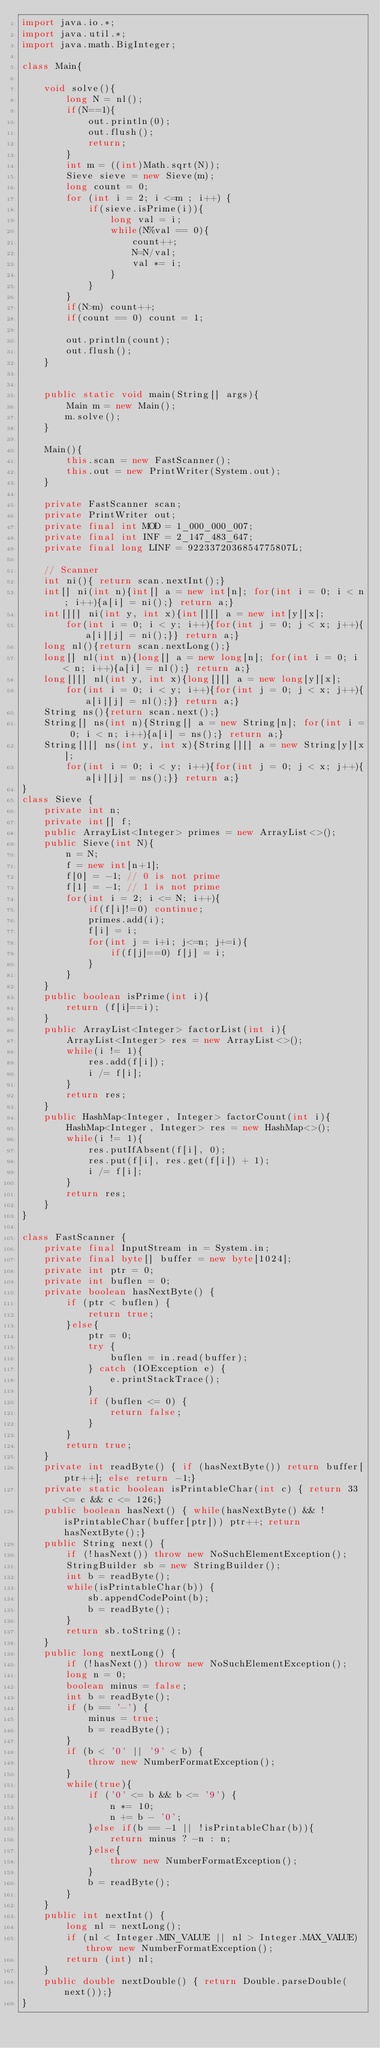Convert code to text. <code><loc_0><loc_0><loc_500><loc_500><_Java_>import java.io.*;
import java.util.*;
import java.math.BigInteger;

class Main{

    void solve(){
        long N = nl();
        if(N==1){
            out.println(0);
            out.flush();
            return;
        }
        int m = ((int)Math.sqrt(N));
        Sieve sieve = new Sieve(m);
        long count = 0;
        for (int i = 2; i <=m ; i++) {
            if(sieve.isPrime(i)){
                long val = i;
                while(N%val == 0){
                    count++;
                    N=N/val;
                    val *= i;
                }
            }
        }
        if(N>m) count++;
        if(count == 0) count = 1;

        out.println(count);
        out.flush();
    } 


    public static void main(String[] args){
        Main m = new Main();
        m.solve();
    }

    Main(){
        this.scan = new FastScanner();
        this.out = new PrintWriter(System.out);
    }

    private FastScanner scan;
    private PrintWriter out;
    private final int MOD = 1_000_000_007;
    private final int INF = 2_147_483_647;
    private final long LINF = 9223372036854775807L;

    // Scanner
    int ni(){ return scan.nextInt();}
    int[] ni(int n){int[] a = new int[n]; for(int i = 0; i < n; i++){a[i] = ni();} return a;}
    int[][] ni(int y, int x){int[][] a = new int[y][x];
        for(int i = 0; i < y; i++){for(int j = 0; j < x; j++){a[i][j] = ni();}} return a;}
    long nl(){return scan.nextLong();}
    long[] nl(int n){long[] a = new long[n]; for(int i = 0; i < n; i++){a[i] = nl();} return a;}
    long[][] nl(int y, int x){long[][] a = new long[y][x];
        for(int i = 0; i < y; i++){for(int j = 0; j < x; j++){a[i][j] = nl();}} return a;}
    String ns(){return scan.next();}
    String[] ns(int n){String[] a = new String[n]; for(int i = 0; i < n; i++){a[i] = ns();} return a;}
    String[][] ns(int y, int x){String[][] a = new String[y][x];
        for(int i = 0; i < y; i++){for(int j = 0; j < x; j++){a[i][j] = ns();}} return a;}
}
class Sieve {
    private int n;
    private int[] f;
    public ArrayList<Integer> primes = new ArrayList<>();
    public Sieve(int N){
        n = N;
        f = new int[n+1];
        f[0] = -1; // 0 is not prime
        f[1] = -1; // 1 is not prime
        for(int i = 2; i <= N; i++){
            if(f[i]!=0) continue;
            primes.add(i);
            f[i] = i;
            for(int j = i+i; j<=n; j+=i){
                if(f[j]==0) f[j] = i;
            }
        }
    }
    public boolean isPrime(int i){
        return (f[i]==i);
    } 
    public ArrayList<Integer> factorList(int i){
        ArrayList<Integer> res = new ArrayList<>();
        while(i != 1){
            res.add(f[i]);
            i /= f[i];
        }
        return res;
    }
    public HashMap<Integer, Integer> factorCount(int i){
        HashMap<Integer, Integer> res = new HashMap<>();
        while(i != 1){
            res.putIfAbsent(f[i], 0);
            res.put(f[i], res.get(f[i]) + 1);
            i /= f[i];
        }
        return res;
    }
}

class FastScanner {
    private final InputStream in = System.in;
    private final byte[] buffer = new byte[1024];
    private int ptr = 0;
    private int buflen = 0;
    private boolean hasNextByte() {
        if (ptr < buflen) {
            return true;
        }else{
            ptr = 0;
            try {
                buflen = in.read(buffer);
            } catch (IOException e) {
                e.printStackTrace();
            }
            if (buflen <= 0) {
                return false;
            }
        }
        return true;
    }
    private int readByte() { if (hasNextByte()) return buffer[ptr++]; else return -1;}
    private static boolean isPrintableChar(int c) { return 33 <= c && c <= 126;}
    public boolean hasNext() { while(hasNextByte() && !isPrintableChar(buffer[ptr])) ptr++; return hasNextByte();}
    public String next() {
        if (!hasNext()) throw new NoSuchElementException();
        StringBuilder sb = new StringBuilder();
        int b = readByte();
        while(isPrintableChar(b)) {
            sb.appendCodePoint(b);
            b = readByte();
        }
        return sb.toString();
    }
    public long nextLong() {
        if (!hasNext()) throw new NoSuchElementException();
        long n = 0;
        boolean minus = false;
        int b = readByte();
        if (b == '-') {
            minus = true;
            b = readByte();
        }
        if (b < '0' || '9' < b) {
            throw new NumberFormatException();
        }
        while(true){
            if ('0' <= b && b <= '9') {
                n *= 10;
                n += b - '0';
            }else if(b == -1 || !isPrintableChar(b)){
                return minus ? -n : n;
            }else{
                throw new NumberFormatException();
            }
            b = readByte();
        }
    }
    public int nextInt() {
        long nl = nextLong();
        if (nl < Integer.MIN_VALUE || nl > Integer.MAX_VALUE) throw new NumberFormatException();
        return (int) nl;
    }
    public double nextDouble() { return Double.parseDouble(next());}
}
</code> 